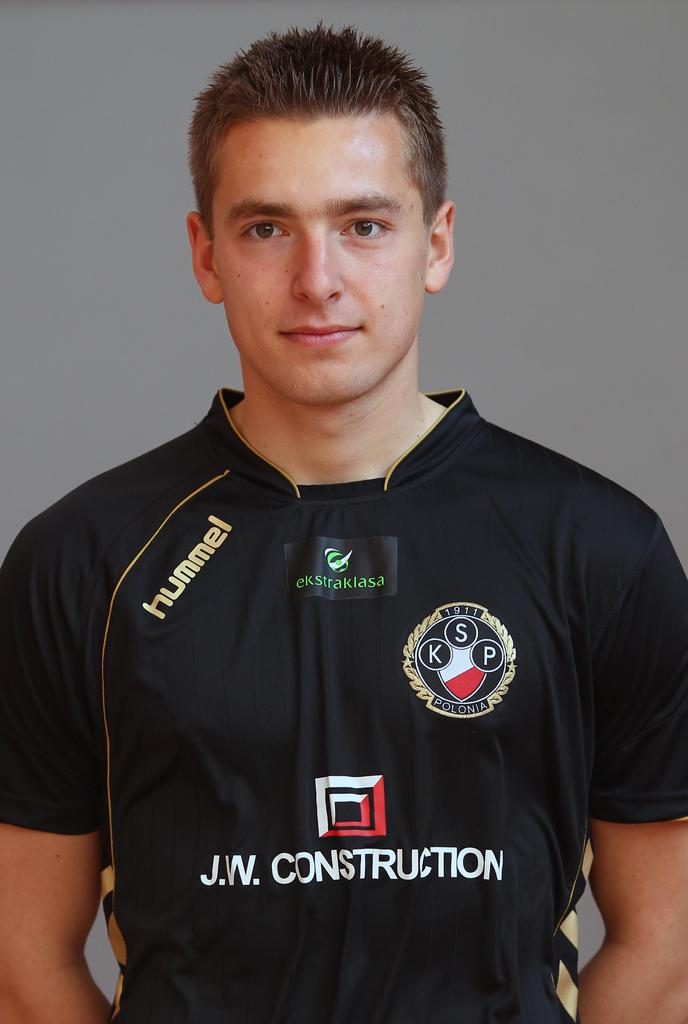<image>
Offer a succinct explanation of the picture presented. A young man wears a shirt with "hummel" and "J.W. Construction on the front. 